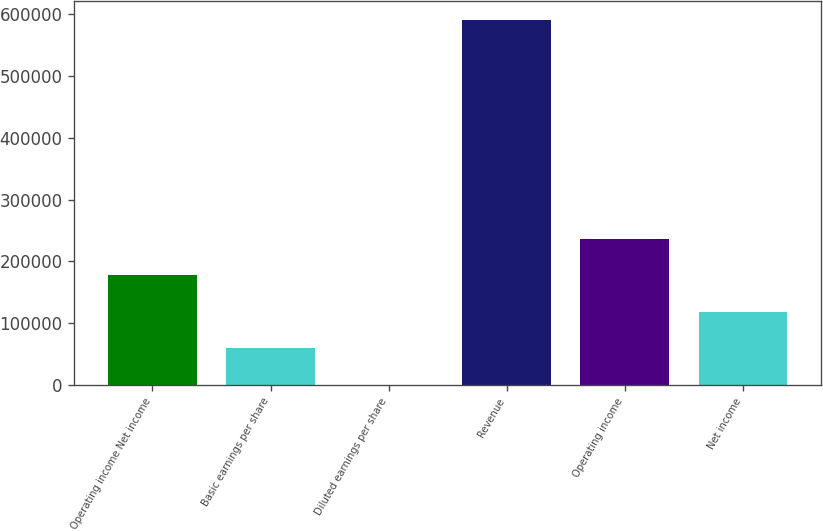Convert chart. <chart><loc_0><loc_0><loc_500><loc_500><bar_chart><fcel>Operating income Net income<fcel>Basic earnings per share<fcel>Diluted earnings per share<fcel>Revenue<fcel>Operating income<fcel>Net income<nl><fcel>177558<fcel>59187.4<fcel>2.27<fcel>591854<fcel>236743<fcel>118373<nl></chart> 